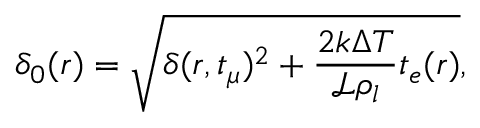<formula> <loc_0><loc_0><loc_500><loc_500>\delta _ { 0 } ( r ) = \sqrt { \delta ( r , t _ { \mu } ) ^ { 2 } + \frac { 2 k \Delta T } { \mathcal { L } \rho _ { l } } t _ { e } ( r ) } ,</formula> 